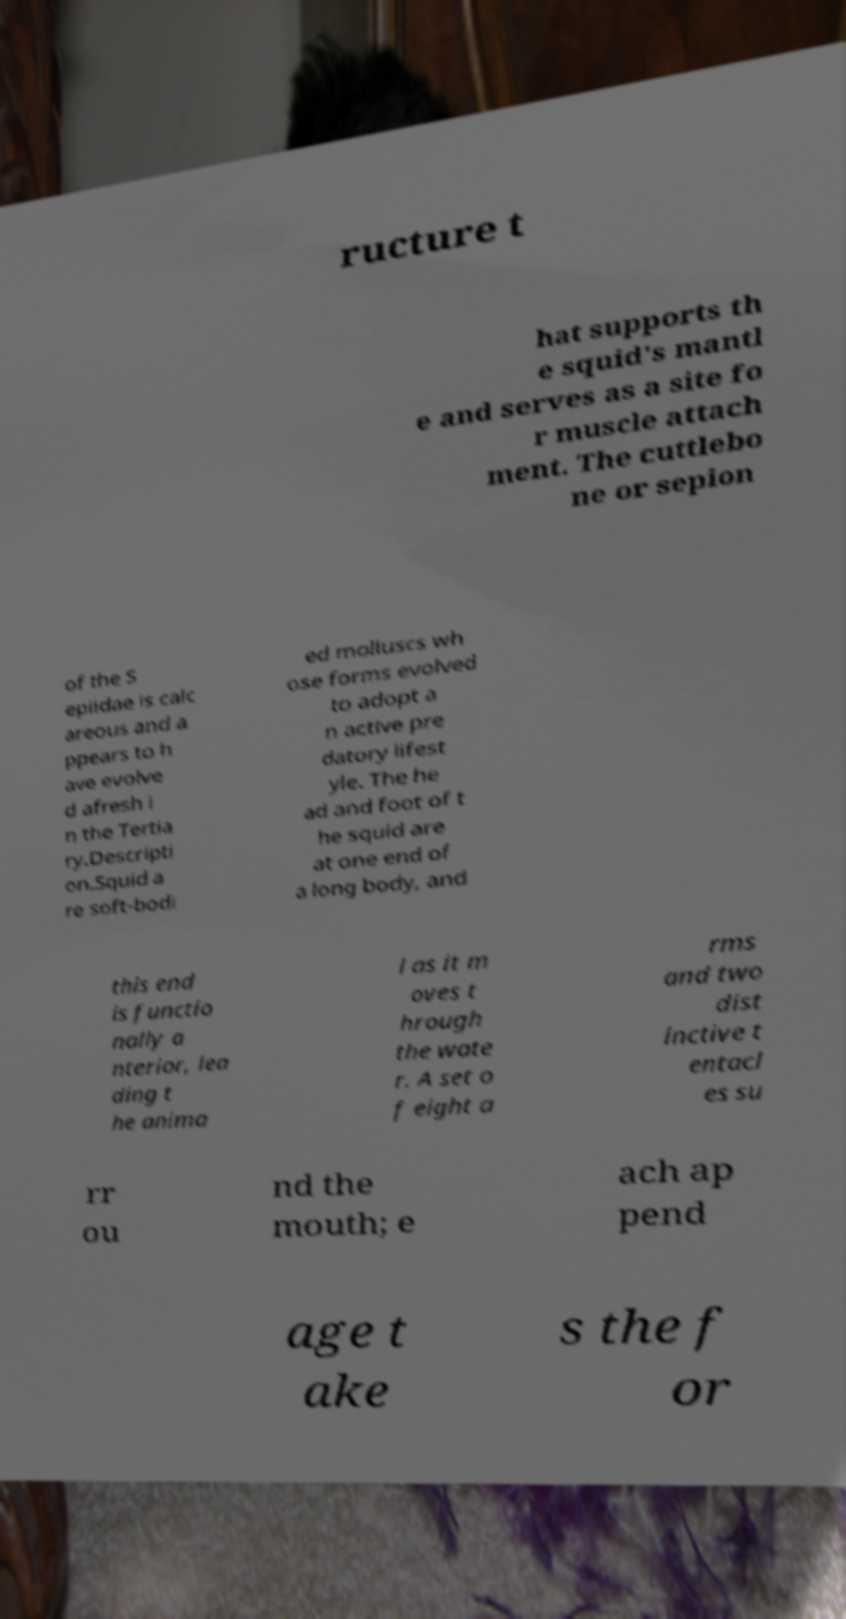Could you assist in decoding the text presented in this image and type it out clearly? ructure t hat supports th e squid's mantl e and serves as a site fo r muscle attach ment. The cuttlebo ne or sepion of the S epiidae is calc areous and a ppears to h ave evolve d afresh i n the Tertia ry.Descripti on.Squid a re soft-bodi ed molluscs wh ose forms evolved to adopt a n active pre datory lifest yle. The he ad and foot of t he squid are at one end of a long body, and this end is functio nally a nterior, lea ding t he anima l as it m oves t hrough the wate r. A set o f eight a rms and two dist inctive t entacl es su rr ou nd the mouth; e ach ap pend age t ake s the f or 